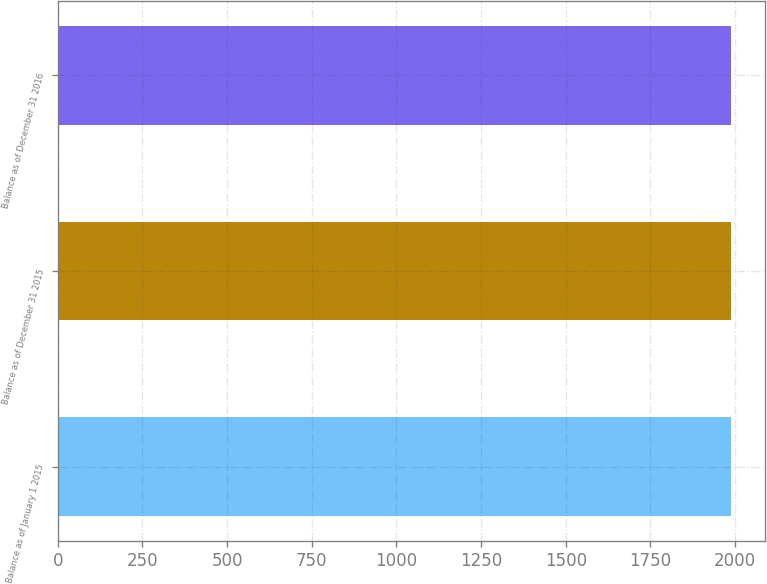<chart> <loc_0><loc_0><loc_500><loc_500><bar_chart><fcel>Balance as of January 1 2015<fcel>Balance as of December 31 2015<fcel>Balance as of December 31 2016<nl><fcel>1988<fcel>1988.1<fcel>1988.2<nl></chart> 